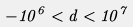Convert formula to latex. <formula><loc_0><loc_0><loc_500><loc_500>- 1 0 ^ { 6 } < d < 1 0 ^ { 7 }</formula> 